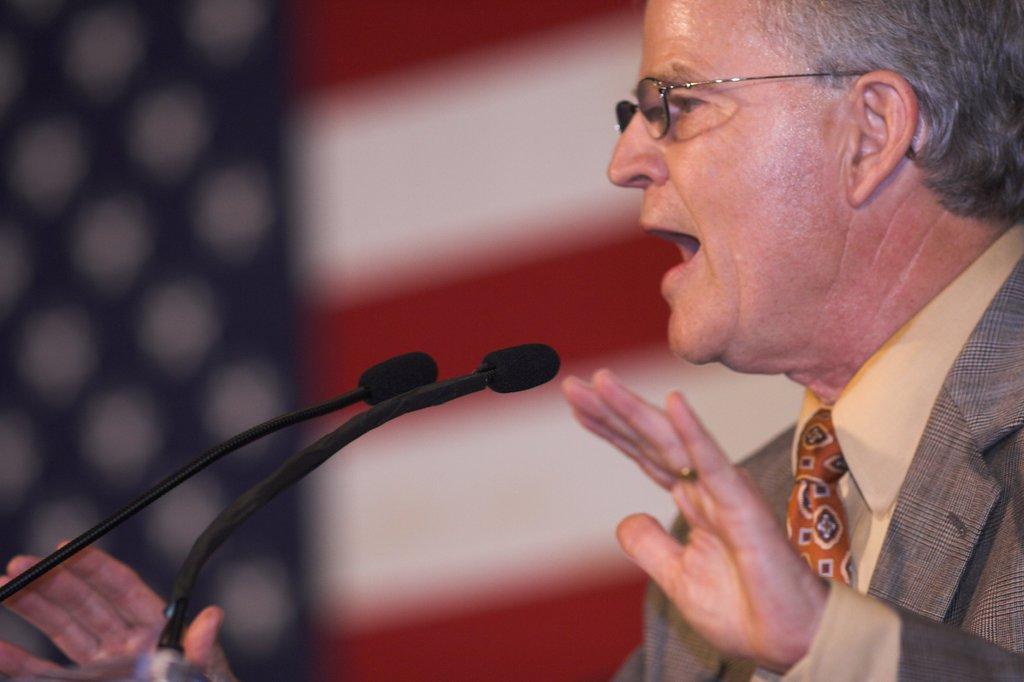What is the main subject of the image? There is a person in the image. What type of clothing is the person wearing? The person is wearing a blazer, a shirt, and a tie. What accessory is the person wearing on their face? The person is wearing specs. What objects are in front of the person? There are two microphones in front of the person. How would you describe the background of the image? The background of the image is blurred. How does the person push away the pest in the image? There is no pest present in the image, so the person cannot push it away. 